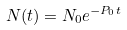<formula> <loc_0><loc_0><loc_500><loc_500>N ( t ) = N _ { 0 } e ^ { - P _ { 0 } t }</formula> 